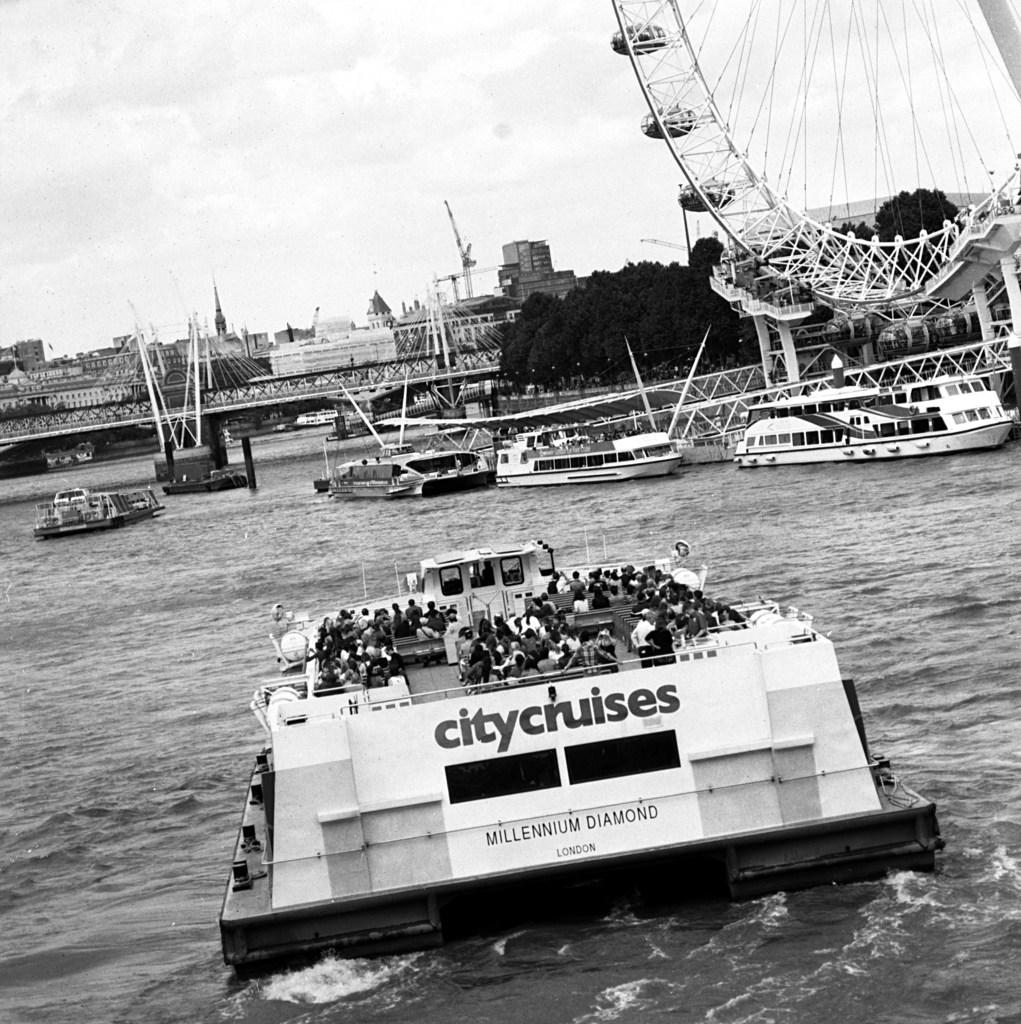<image>
Present a compact description of the photo's key features. A boat has a city cruises logo on the back. 